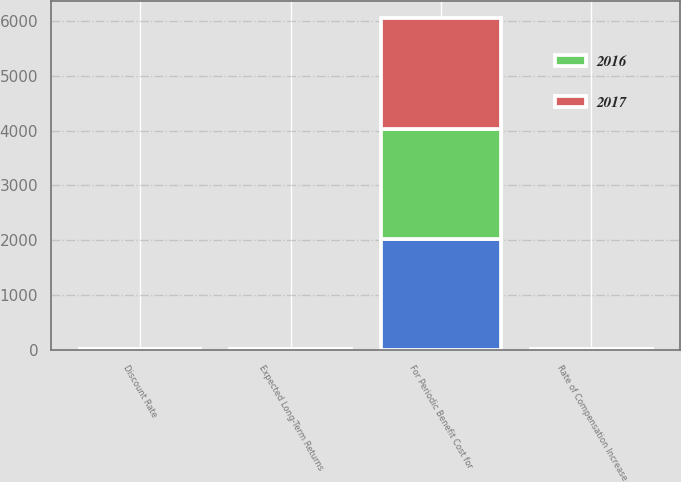<chart> <loc_0><loc_0><loc_500><loc_500><stacked_bar_chart><ecel><fcel>For Periodic Benefit Cost for<fcel>Discount Rate<fcel>Expected Long-Term Returns<fcel>Rate of Compensation Increase<nl><fcel>2017<fcel>2017<fcel>4.27<fcel>6.96<fcel>4.31<nl><fcel>nan<fcel>2016<fcel>4.64<fcel>7.19<fcel>4.33<nl><fcel>2016<fcel>2015<fcel>4.23<fcel>6.96<fcel>4.35<nl></chart> 